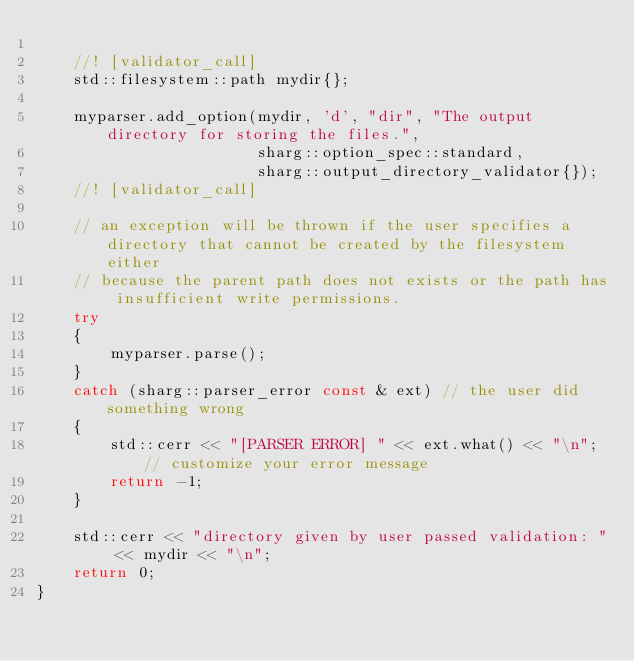<code> <loc_0><loc_0><loc_500><loc_500><_C++_>
    //! [validator_call]
    std::filesystem::path mydir{};

    myparser.add_option(mydir, 'd', "dir", "The output directory for storing the files.",
                        sharg::option_spec::standard,
                        sharg::output_directory_validator{});
    //! [validator_call]

    // an exception will be thrown if the user specifies a directory that cannot be created by the filesystem either
    // because the parent path does not exists or the path has insufficient write permissions.
    try
    {
        myparser.parse();
    }
    catch (sharg::parser_error const & ext) // the user did something wrong
    {
        std::cerr << "[PARSER ERROR] " << ext.what() << "\n"; // customize your error message
        return -1;
    }

    std::cerr << "directory given by user passed validation: " << mydir << "\n";
    return 0;
}
</code> 